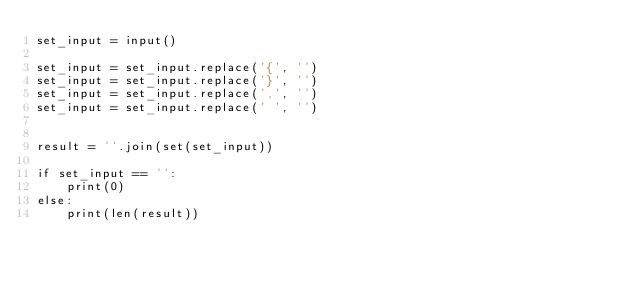<code> <loc_0><loc_0><loc_500><loc_500><_Python_>set_input = input()

set_input = set_input.replace('{', '')
set_input = set_input.replace('}', '')
set_input = set_input.replace(',', '')
set_input = set_input.replace(' ', '')


result = ''.join(set(set_input))

if set_input == '':
    print(0)
else:
    print(len(result))
</code> 